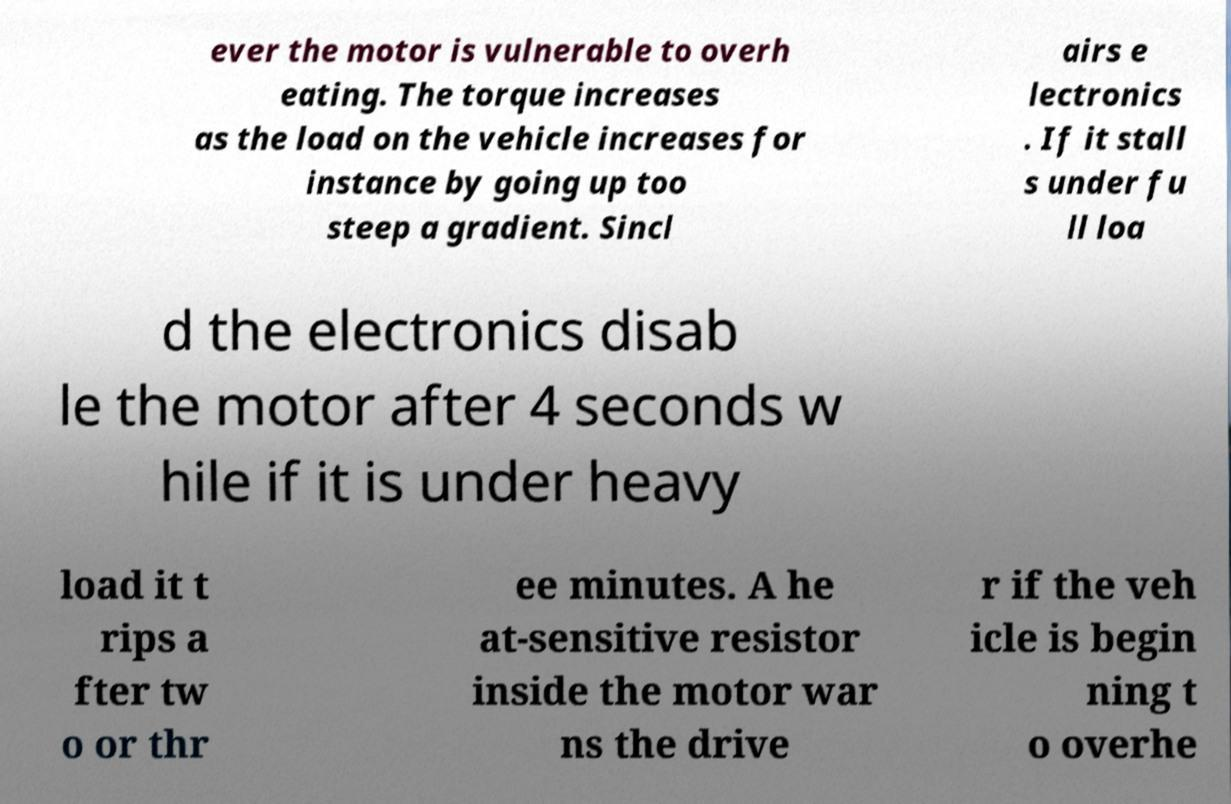For documentation purposes, I need the text within this image transcribed. Could you provide that? ever the motor is vulnerable to overh eating. The torque increases as the load on the vehicle increases for instance by going up too steep a gradient. Sincl airs e lectronics . If it stall s under fu ll loa d the electronics disab le the motor after 4 seconds w hile if it is under heavy load it t rips a fter tw o or thr ee minutes. A he at-sensitive resistor inside the motor war ns the drive r if the veh icle is begin ning t o overhe 